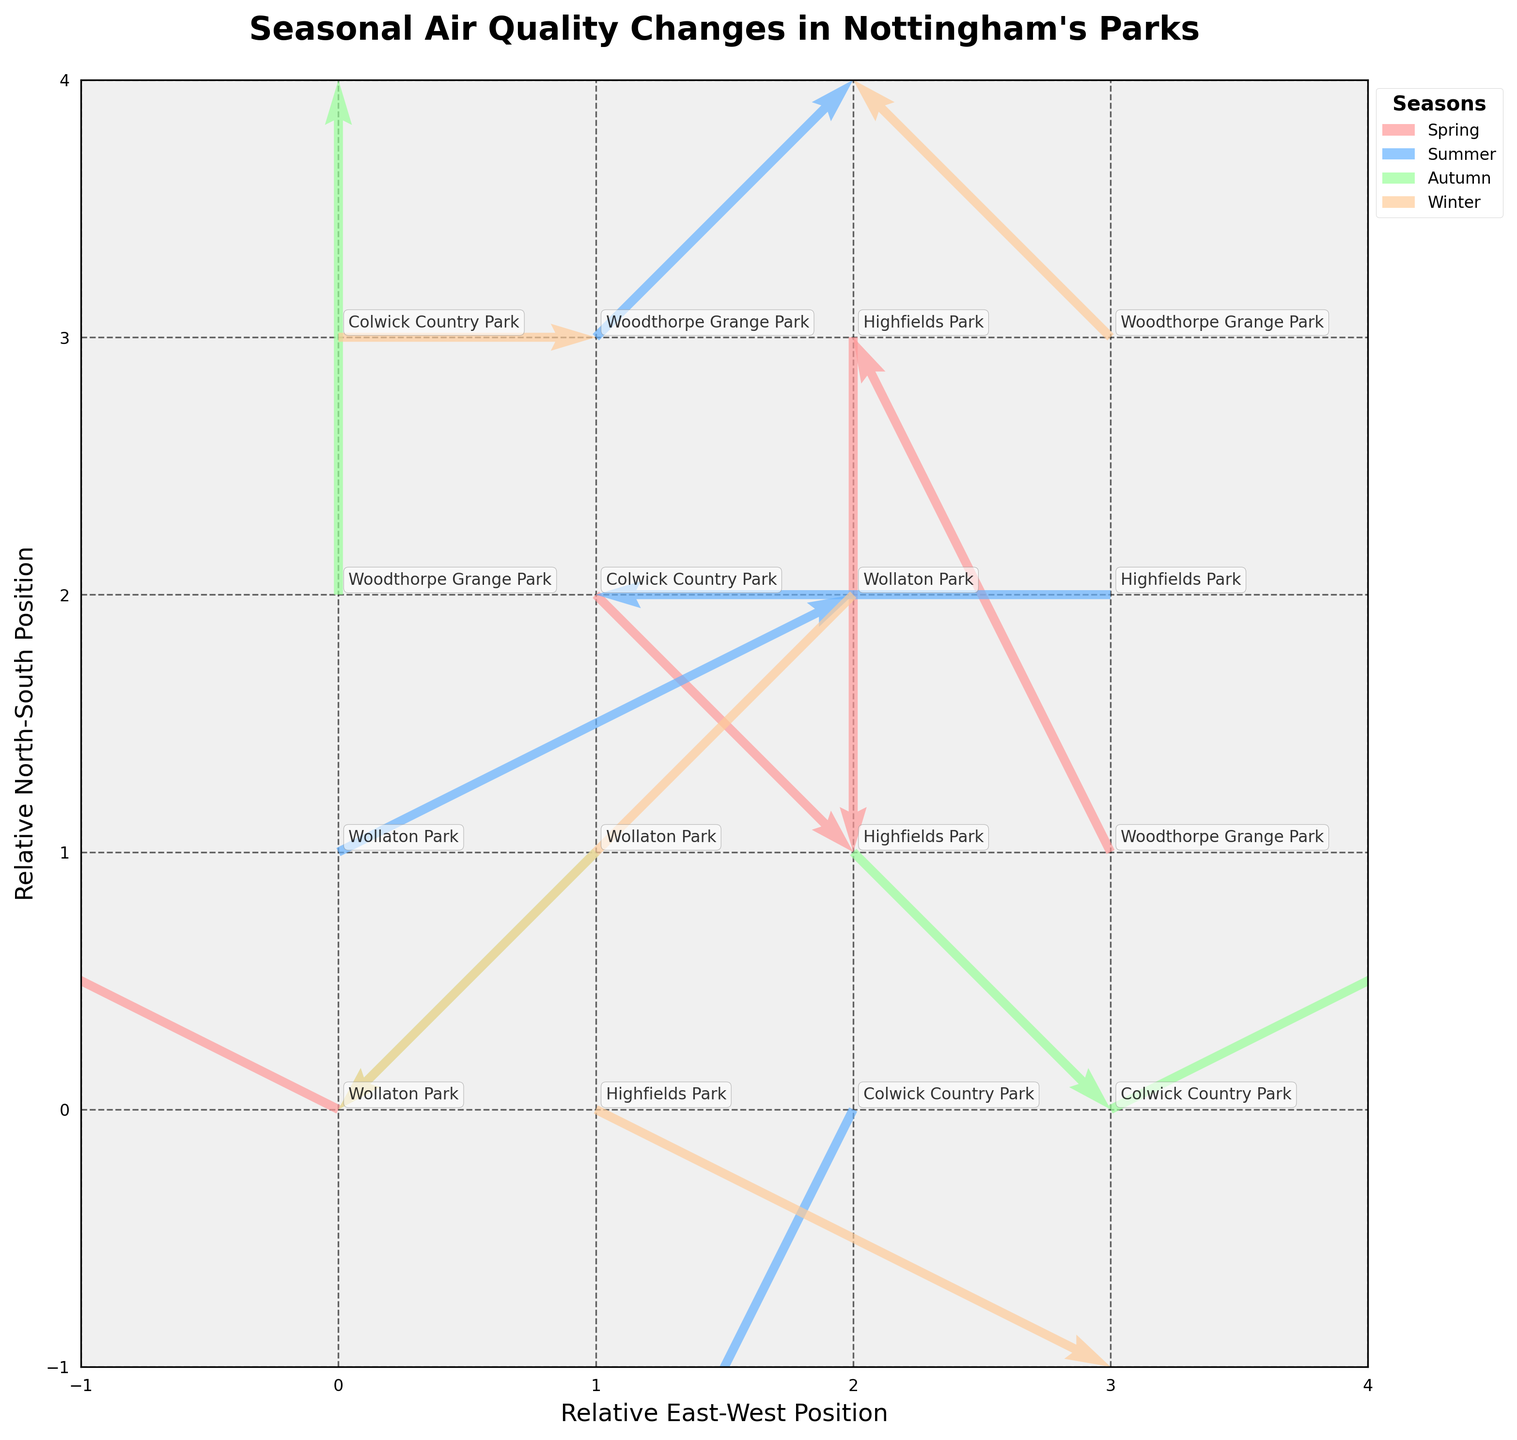What's the main title of the figure? The main title is usually positioned at the top of the chart and often in a larger font than other text. In this case, the title is "Seasonal Air Quality Changes in Nottingham's Parks."
Answer: Seasonal Air Quality Changes in Nottingham's Parks How many seasons are displayed in the figure? The legend on the right-hand side of the figure lists the seasons. There are four colors each representing a different season. This gives us the total number of seasons displayed.
Answer: 4 Which park in Autumn shows pollutants dispersing eastward and slightly northward? Look for the quiver arrows representing Autumn. Identify the direction of the arrows for each park. In this case, Colwick Country Park has an arrow with direction (2,1), which is eastward and slightly northward.
Answer: Colwick Country Park Is there any park where pollutants are stagnant (i.e., no dispersal) in any season? Check for arrows with (0,0) direction vector across all seasons. There are no such arrows visible in the figure, indicating that none of the parks have stagnant pollutants.
Answer: No Which park and season experienced the strongest westward pollutant dispersal? Look for the longest and most westward vector arrows pointing left (negative x-direction). In Winter, Wollaton Park has the strongest westward dispersal with a vector (-2, -2).
Answer: Wollaton Park, Winter How does the pollutant dispersal direction in Woodthorpe Grange Park during Summer compare to that during Winter? Examine the direction vectors for Woodthorpe Grange Park in Summer and Winter. In Summer, the direction is (1,1), which is northeast. In Winter, the direction is (-1,1), northwest.
Answer: Northeast in Summer, Northwest in Winter In which location do pollutants disperse southward during Spring, and what's the displacement direction? Look for Spring season arrows pointing southward (negative y-direction). In Highfields Park, the arrow direction is (0,-2) which means it disperses straight southward.
Answer: Highfields Park, southward What is the general trend of pollutant dispersal in Wollaton Park across all seasons? Check the direction vectors for Wollaton Park in each season: Spring (-2,1), Summer (2,1), Autumn (-1,-1), Winter (-2,-2). Summarize these trends.
Answer: West in Spring, East in Summer, Southeast in Autumn, Southwest in Winter Which season and location experienced no east-west pollutant dispersal but only north-south dispersal in Autumn? Identify arrows in Autumn where the x-component is 0. In Woodthorpe Grange Park, the direction vector is (0,2) indicating only northward dispersal.
Answer: Autumn, Woodthorpe Grange Park 